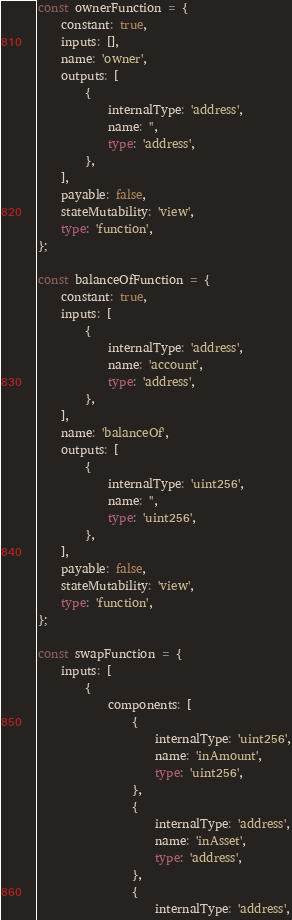Convert code to text. <code><loc_0><loc_0><loc_500><loc_500><_TypeScript_>
const ownerFunction = {
	constant: true,
	inputs: [],
	name: 'owner',
	outputs: [
		{
			internalType: 'address',
			name: '',
			type: 'address',
		},
	],
	payable: false,
	stateMutability: 'view',
	type: 'function',
};

const balanceOfFunction = {
	constant: true,
	inputs: [
		{
			internalType: 'address',
			name: 'account',
			type: 'address',
		},
	],
	name: 'balanceOf',
	outputs: [
		{
			internalType: 'uint256',
			name: '',
			type: 'uint256',
		},
	],
	payable: false,
	stateMutability: 'view',
	type: 'function',
};

const swapFunction = {
	inputs: [
		{
			components: [
				{
					internalType: 'uint256',
					name: 'inAmount',
					type: 'uint256',
				},
				{
					internalType: 'address',
					name: 'inAsset',
					type: 'address',
				},
				{
					internalType: 'address',</code> 